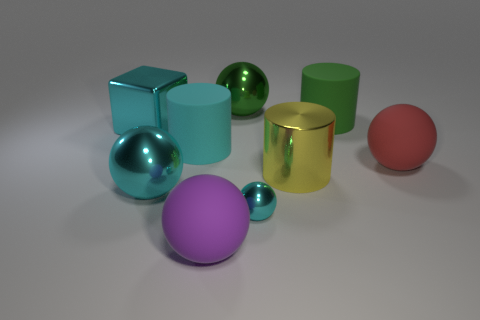The other rubber thing that is the same color as the small thing is what shape?
Give a very brief answer. Cylinder. Does the sphere to the left of the large purple rubber ball have the same material as the ball to the right of the big yellow metallic cylinder?
Ensure brevity in your answer.  No. What is the color of the tiny sphere?
Offer a very short reply. Cyan. How many other big green matte objects have the same shape as the big green matte thing?
Provide a short and direct response. 0. The shiny cylinder that is the same size as the purple object is what color?
Provide a succinct answer. Yellow. Are any large blue shiny balls visible?
Ensure brevity in your answer.  No. The large matte object in front of the small cyan ball has what shape?
Your response must be concise. Sphere. How many metallic things are in front of the cyan block and behind the big yellow metal cylinder?
Offer a very short reply. 0. Is there a cyan cylinder that has the same material as the big cube?
Your answer should be very brief. No. What size is the matte cylinder that is the same color as the metal cube?
Your response must be concise. Large. 